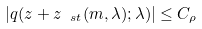Convert formula to latex. <formula><loc_0><loc_0><loc_500><loc_500>| q ( z + z _ { \ s t } ( m , \lambda ) ; \lambda ) | \leq C _ { \rho }</formula> 